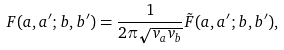Convert formula to latex. <formula><loc_0><loc_0><loc_500><loc_500>F ( a , a ^ { \prime } ; b , b ^ { \prime } ) = \frac { 1 } { 2 \pi \sqrt { v _ { a } v _ { b } } } \tilde { F } ( a , a ^ { \prime } ; b , b ^ { \prime } ) ,</formula> 